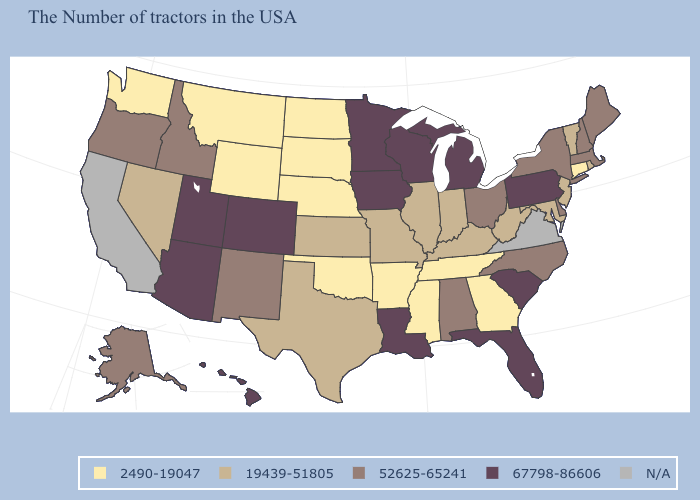Which states have the lowest value in the West?
Short answer required. Wyoming, Montana, Washington. What is the highest value in the MidWest ?
Quick response, please. 67798-86606. What is the value of Mississippi?
Keep it brief. 2490-19047. Name the states that have a value in the range N/A?
Concise answer only. Virginia, California. What is the highest value in the South ?
Write a very short answer. 67798-86606. Which states have the highest value in the USA?
Quick response, please. Pennsylvania, South Carolina, Florida, Michigan, Wisconsin, Louisiana, Minnesota, Iowa, Colorado, Utah, Arizona, Hawaii. Does Pennsylvania have the highest value in the Northeast?
Write a very short answer. Yes. Does Pennsylvania have the highest value in the Northeast?
Keep it brief. Yes. Is the legend a continuous bar?
Give a very brief answer. No. Name the states that have a value in the range N/A?
Concise answer only. Virginia, California. Name the states that have a value in the range 52625-65241?
Answer briefly. Maine, Massachusetts, New Hampshire, New York, Delaware, North Carolina, Ohio, Alabama, New Mexico, Idaho, Oregon, Alaska. Name the states that have a value in the range 19439-51805?
Be succinct. Rhode Island, Vermont, New Jersey, Maryland, West Virginia, Kentucky, Indiana, Illinois, Missouri, Kansas, Texas, Nevada. Does South Dakota have the highest value in the USA?
Write a very short answer. No. 